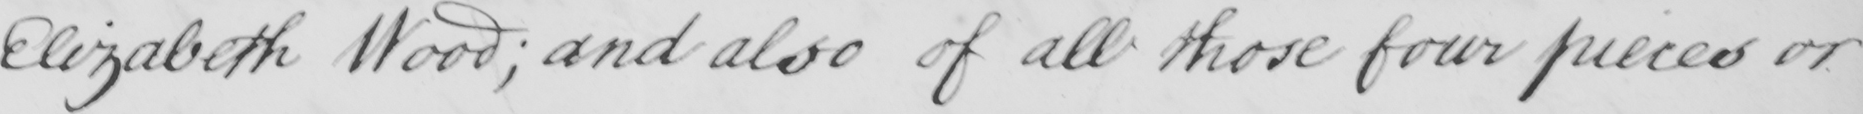Can you read and transcribe this handwriting? Elizabeth Wood ; and also of all those four pieces or 